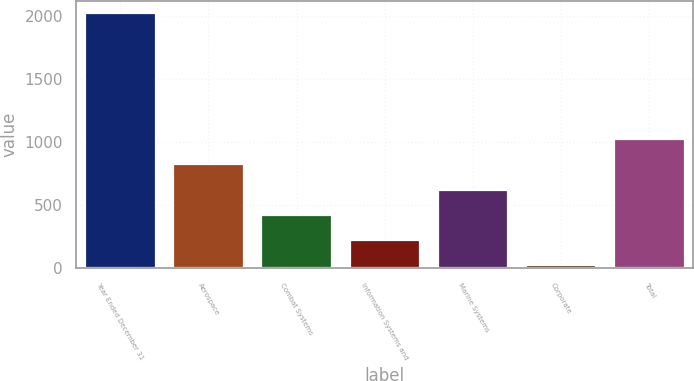<chart> <loc_0><loc_0><loc_500><loc_500><bar_chart><fcel>Year Ended December 31<fcel>Aerospace<fcel>Combat Systems<fcel>Information Systems and<fcel>Marine Systems<fcel>Corporate<fcel>Total<nl><fcel>2017<fcel>822.4<fcel>424.2<fcel>225.1<fcel>623.3<fcel>26<fcel>1021.5<nl></chart> 